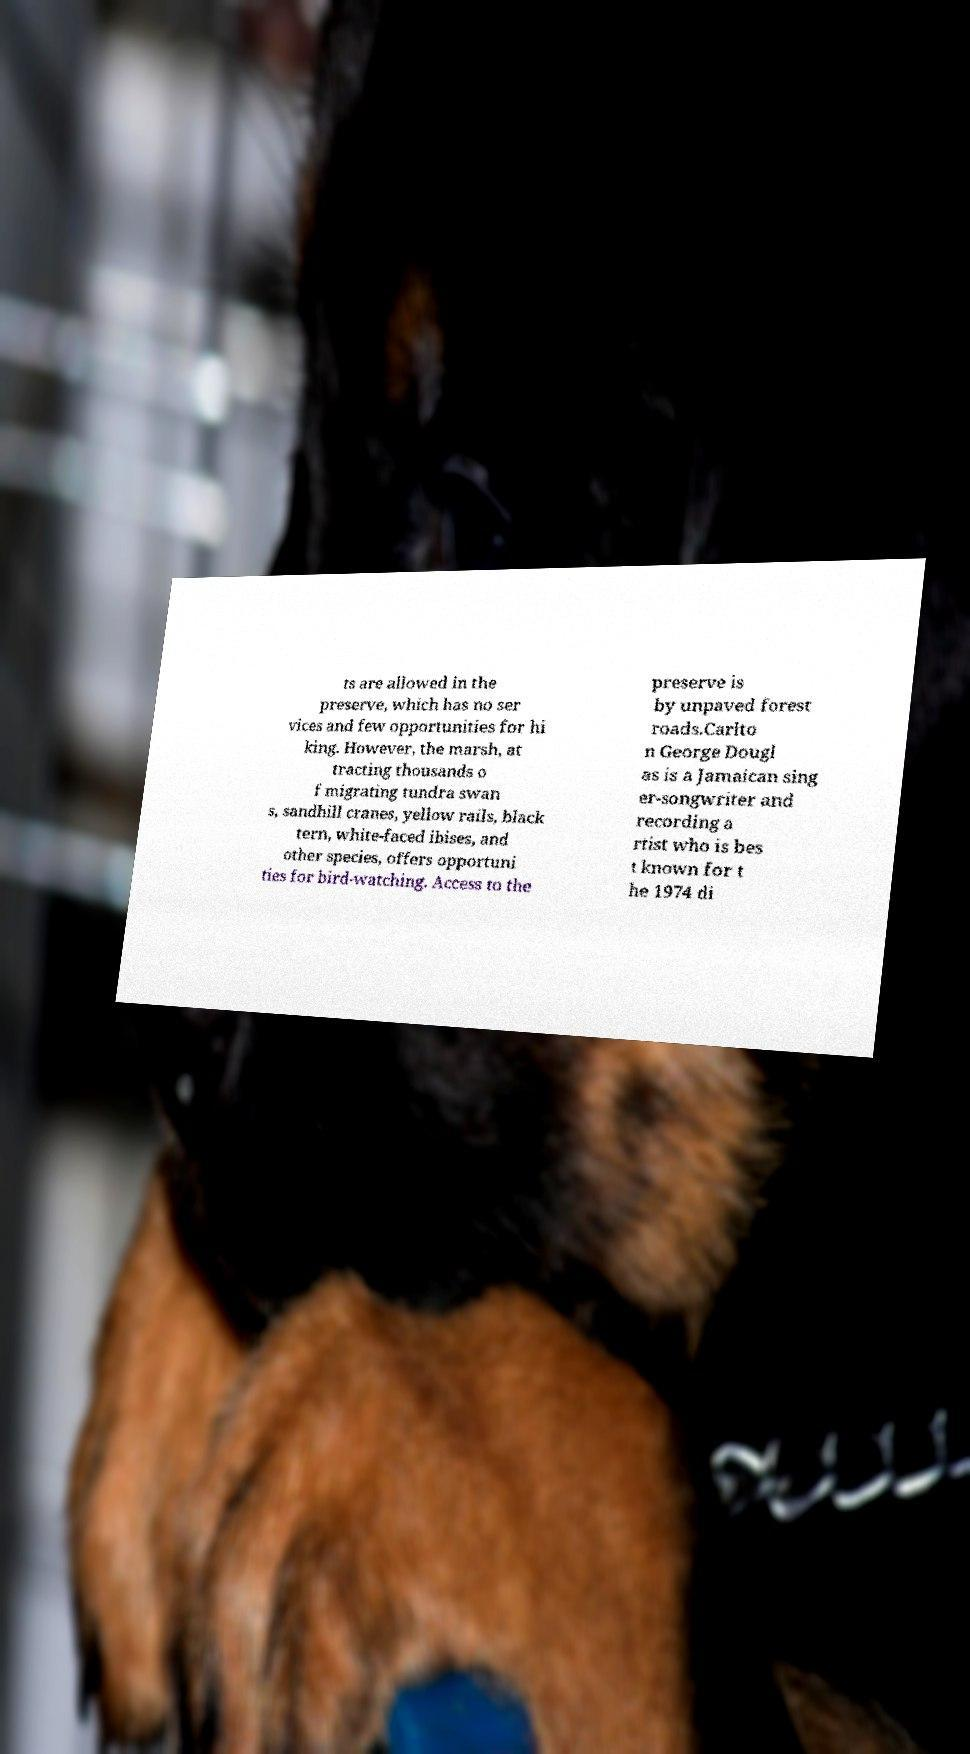Could you extract and type out the text from this image? ts are allowed in the preserve, which has no ser vices and few opportunities for hi king. However, the marsh, at tracting thousands o f migrating tundra swan s, sandhill cranes, yellow rails, black tern, white-faced ibises, and other species, offers opportuni ties for bird-watching. Access to the preserve is by unpaved forest roads.Carlto n George Dougl as is a Jamaican sing er-songwriter and recording a rtist who is bes t known for t he 1974 di 